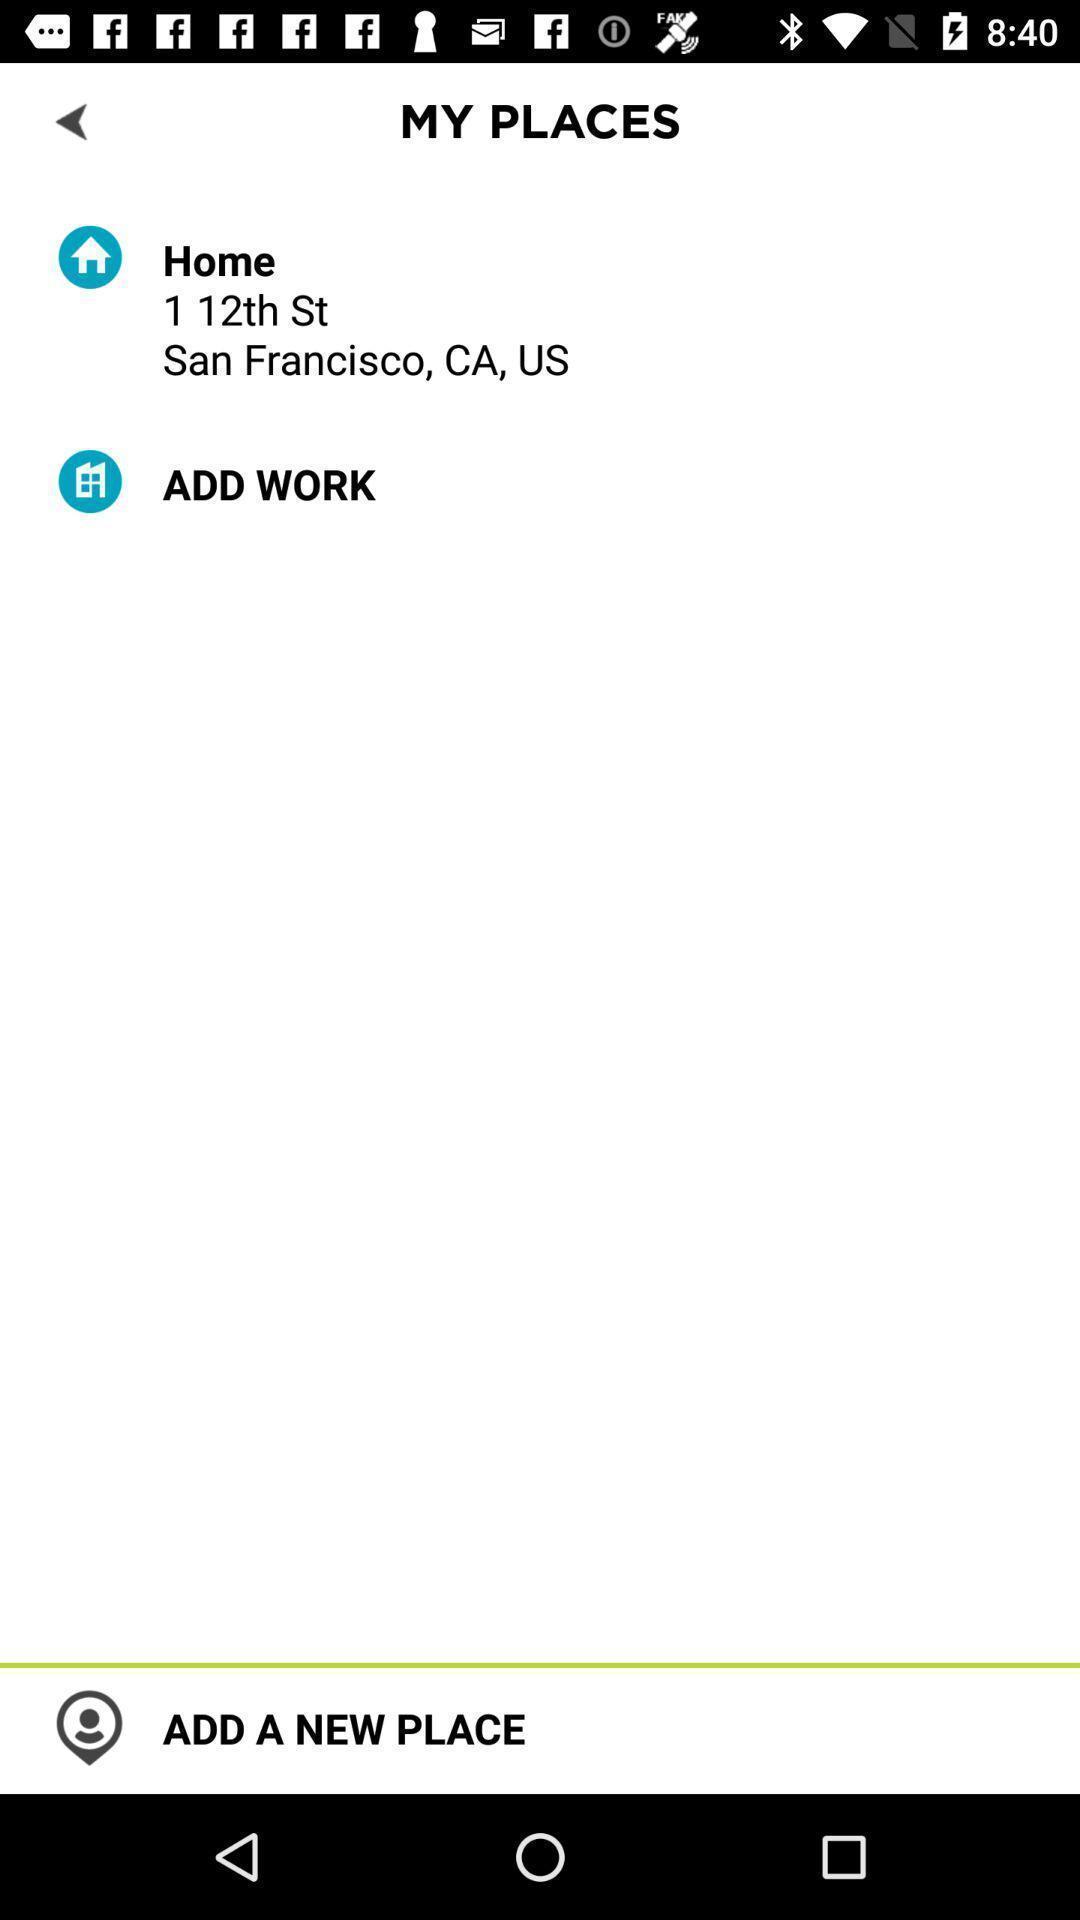Describe the visual elements of this screenshot. Places which have been added in the map application. 